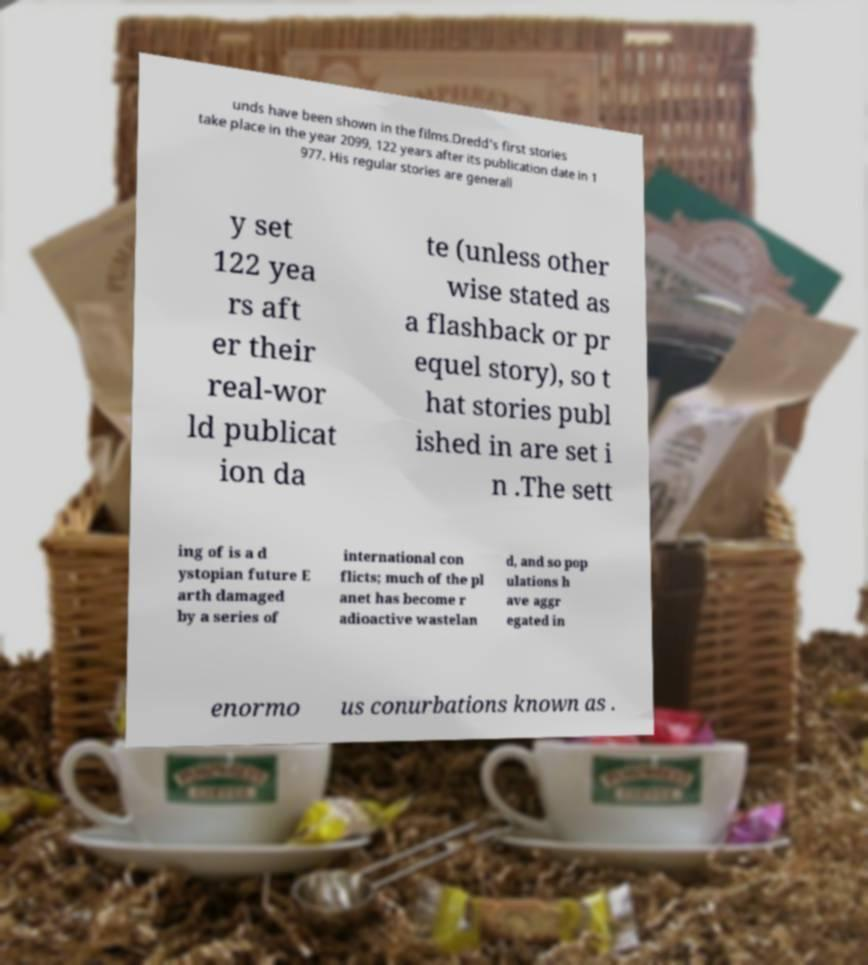Please identify and transcribe the text found in this image. unds have been shown in the films.Dredd's first stories take place in the year 2099, 122 years after its publication date in 1 977. His regular stories are generall y set 122 yea rs aft er their real-wor ld publicat ion da te (unless other wise stated as a flashback or pr equel story), so t hat stories publ ished in are set i n .The sett ing of is a d ystopian future E arth damaged by a series of international con flicts; much of the pl anet has become r adioactive wastelan d, and so pop ulations h ave aggr egated in enormo us conurbations known as . 